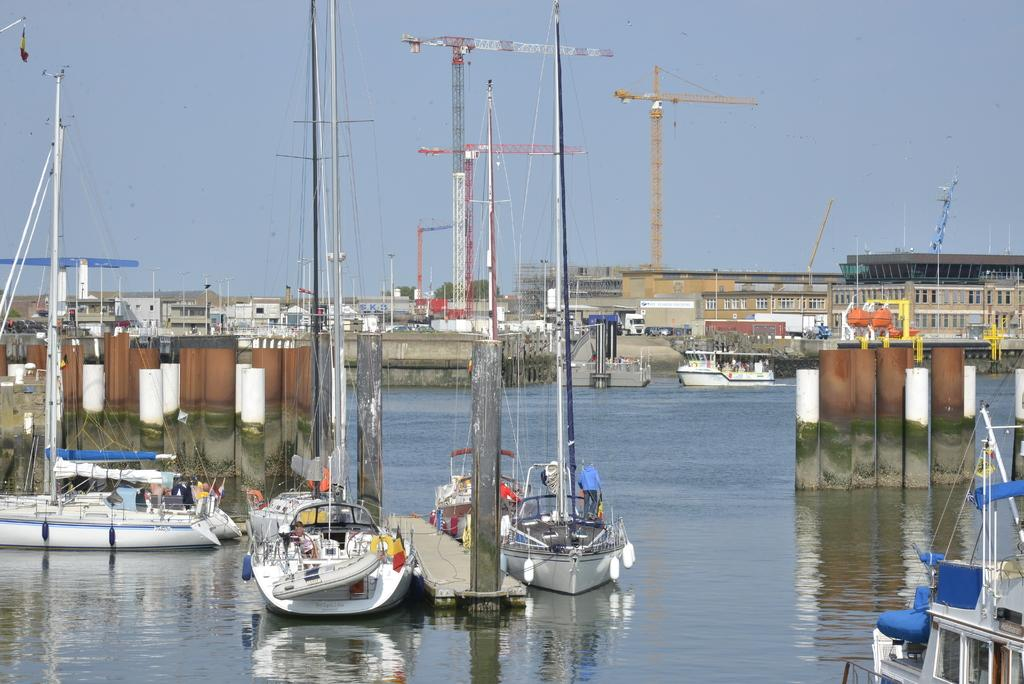What is on the water in the image? There are boats on the water in the image. What type of construction equipment can be seen in the image? Tower cranes are visible in the image. What is in the background of the image? There are buildings in the background of the image. What is visible in the sky in the image? Clouds are present in the sky in the image. What direction is the box facing in the image? There is no box present in the image. What is the mass of the clouds in the image? Clouds do not have a mass in the same way that solid objects do; they are made up of water droplets and ice crystals. 